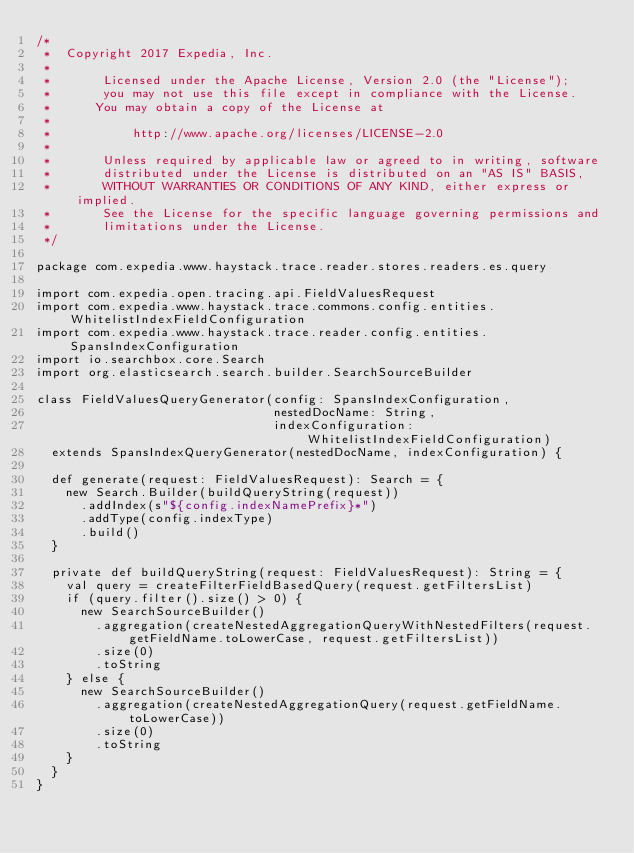<code> <loc_0><loc_0><loc_500><loc_500><_Scala_>/*
 *  Copyright 2017 Expedia, Inc.
 *
 *       Licensed under the Apache License, Version 2.0 (the "License");
 *       you may not use this file except in compliance with the License.
 *      You may obtain a copy of the License at
 *
 *           http://www.apache.org/licenses/LICENSE-2.0
 *
 *       Unless required by applicable law or agreed to in writing, software
 *       distributed under the License is distributed on an "AS IS" BASIS,
 *       WITHOUT WARRANTIES OR CONDITIONS OF ANY KIND, either express or implied.
 *       See the License for the specific language governing permissions and
 *       limitations under the License.
 */

package com.expedia.www.haystack.trace.reader.stores.readers.es.query

import com.expedia.open.tracing.api.FieldValuesRequest
import com.expedia.www.haystack.trace.commons.config.entities.WhitelistIndexFieldConfiguration
import com.expedia.www.haystack.trace.reader.config.entities.SpansIndexConfiguration
import io.searchbox.core.Search
import org.elasticsearch.search.builder.SearchSourceBuilder

class FieldValuesQueryGenerator(config: SpansIndexConfiguration,
                                nestedDocName: String,
                                indexConfiguration: WhitelistIndexFieldConfiguration)
  extends SpansIndexQueryGenerator(nestedDocName, indexConfiguration) {

  def generate(request: FieldValuesRequest): Search = {
    new Search.Builder(buildQueryString(request))
      .addIndex(s"${config.indexNamePrefix}*")
      .addType(config.indexType)
      .build()
  }

  private def buildQueryString(request: FieldValuesRequest): String = {
    val query = createFilterFieldBasedQuery(request.getFiltersList)
    if (query.filter().size() > 0) {
      new SearchSourceBuilder()
        .aggregation(createNestedAggregationQueryWithNestedFilters(request.getFieldName.toLowerCase, request.getFiltersList))
        .size(0)
        .toString
    } else {
      new SearchSourceBuilder()
        .aggregation(createNestedAggregationQuery(request.getFieldName.toLowerCase))
        .size(0)
        .toString
    }
  }
}</code> 